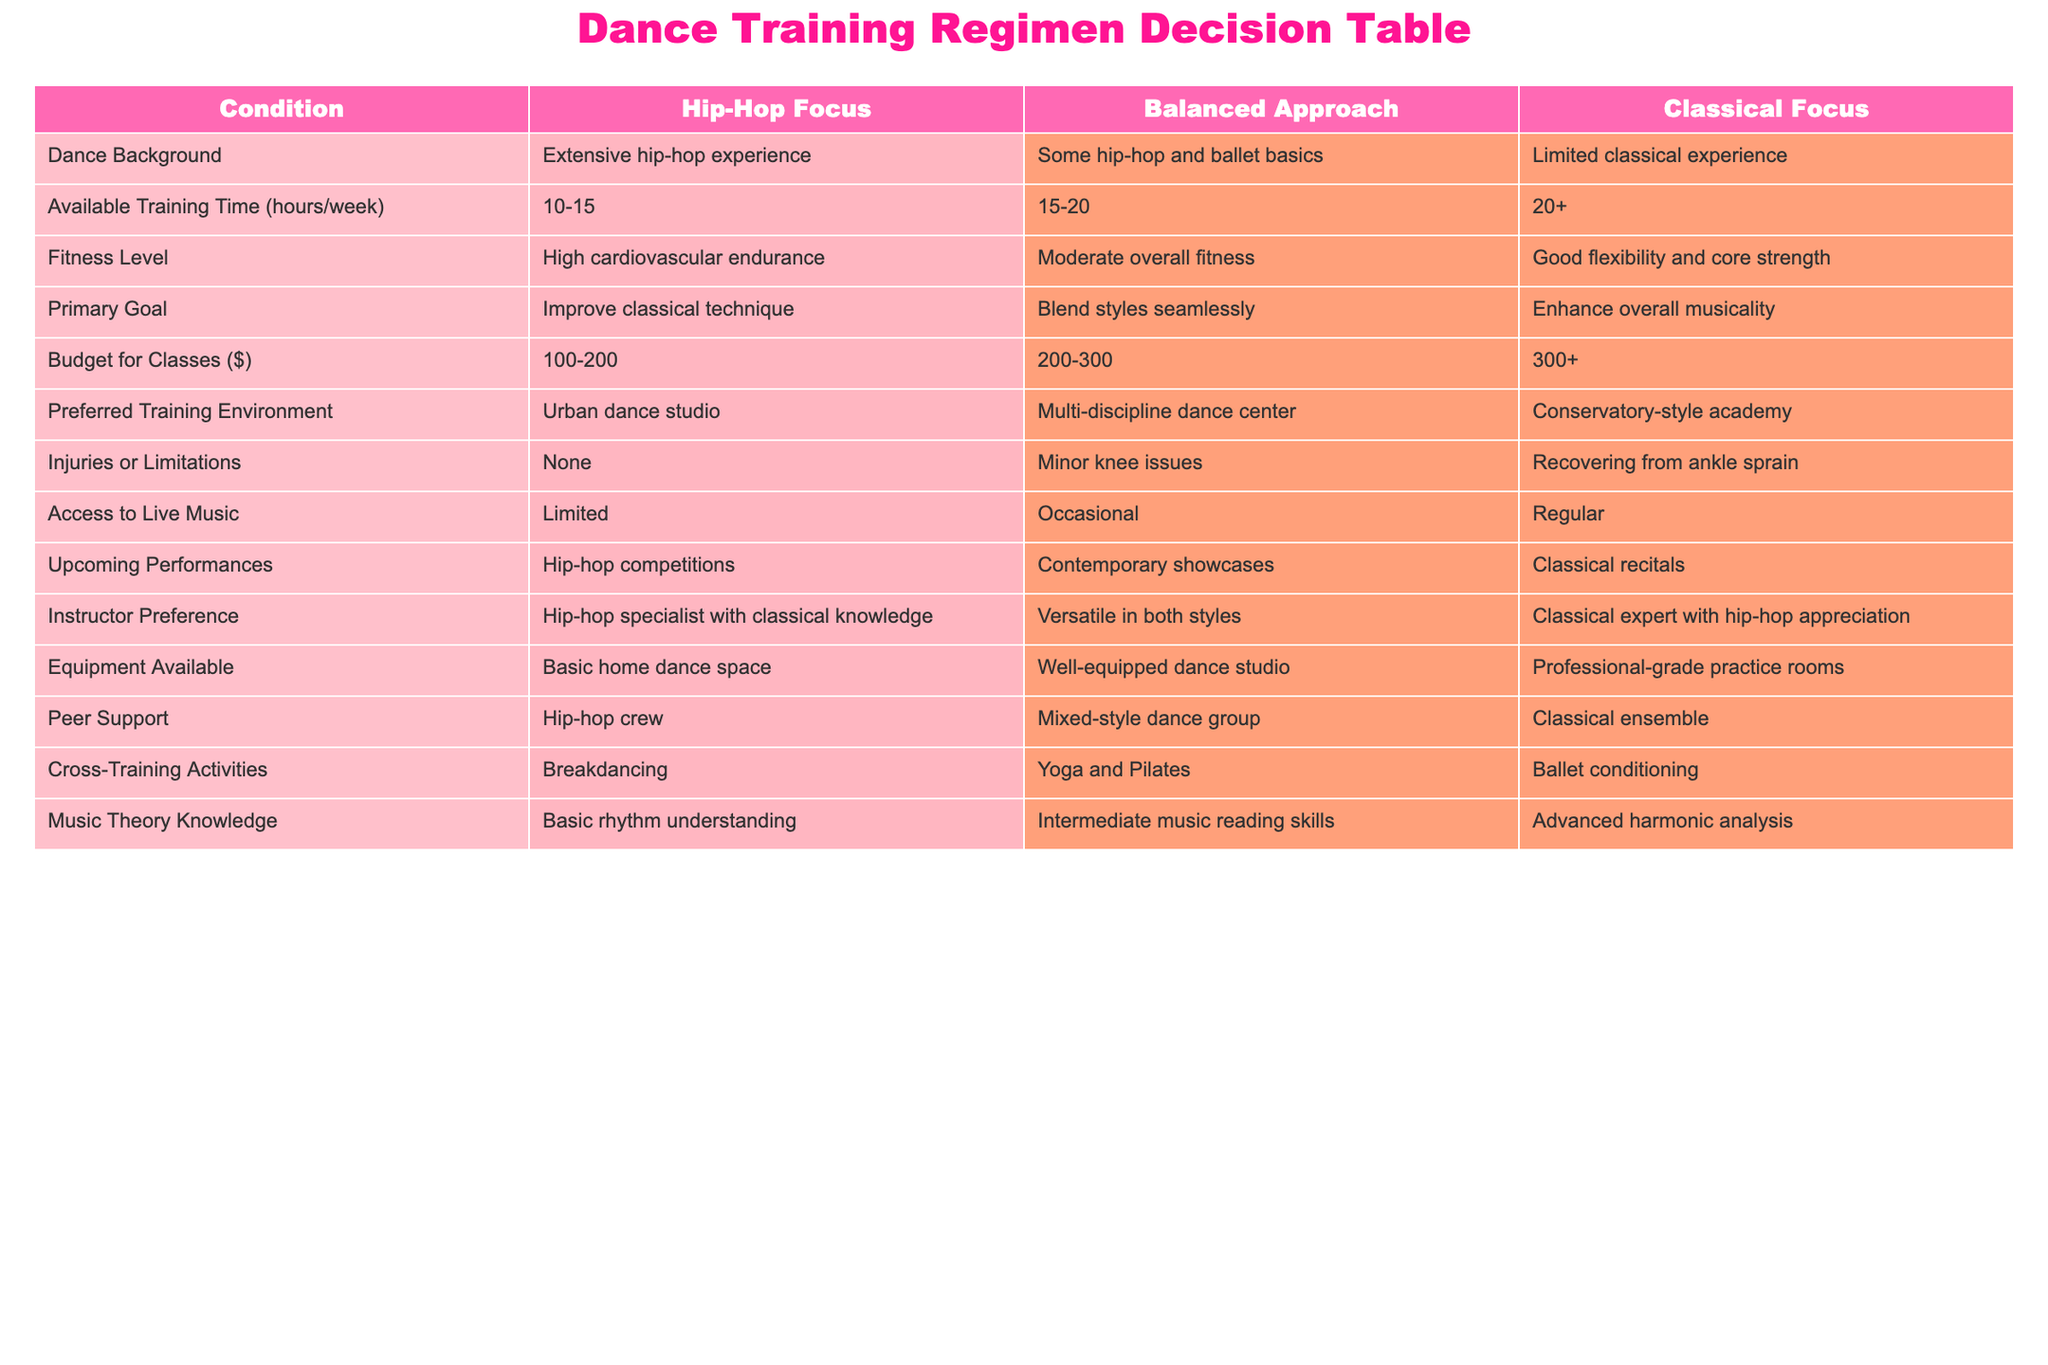What dance background is associated with a classical focus? The table indicates that a classical focus is associated with limited classical experience.
Answer: Limited classical experience What is the budget range for a balanced approach? According to the table, the budget for classes in a balanced approach is set at $200-300.
Answer: $200-300 Is it true that someone with high cardiovascular endurance prefers a hip-hop focus? The data specifically states that those with high cardiovascular endurance have a hip-hop focus, confirming the truth of the statement.
Answer: True What are the three cross-training activities listed for each approach? The table shows that for hip-hop focus it is breakdancing, for a balanced approach it is yoga and Pilates, and for classical focus it is ballet conditioning.
Answer: Breakdancing, Yoga and Pilates, Ballet conditioning Which training environment has access to regular live music? The classical focus training environment is noted to have access to regular live music as per the table.
Answer: Conservatory-style academy What is the difference in available training time between a hip-hop focus and a classical focus? The hip-hop focus has an available training time of 10-15 hours/week, while the classical focus has 20+ hours/week. The difference is calculated as follows: 20 - 15 = 5; since 15 is the highest in hip-hop focus, we take 20 from classical as the difference.
Answer: 5+ hours Which approach has the highest overall fitness level requirement? By examining the fitness level descriptions, the classical focus mentions good flexibility and core strength, which is not articulated as high as hip-hop's high cardiovascular endurance. Thus, hip-hop focus is the highest level requirement.
Answer: Hip-hop focus What is the primary goal for someone pursuing a balanced approach? The table states that the primary goal for a balanced approach is to blend styles seamlessly.
Answer: Blend styles seamlessly If someone is recovering from an ankle sprain, which approach would they likely choose? Since the classical focus has a mention of being associated with recovering from an ankle sprain, it suggests that this individual might favor that option while recovering.
Answer: Classical focus 